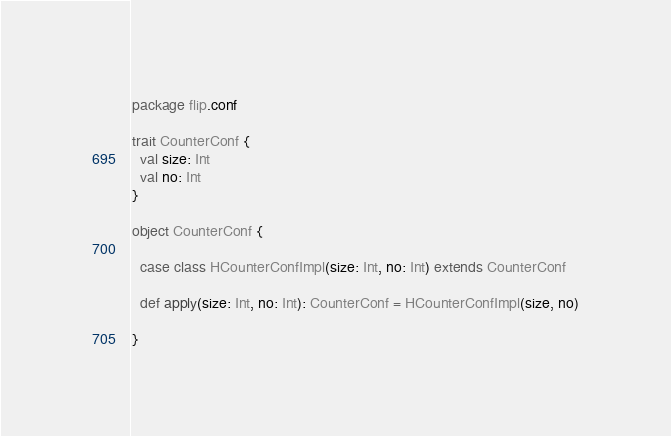Convert code to text. <code><loc_0><loc_0><loc_500><loc_500><_Scala_>package flip.conf

trait CounterConf {
  val size: Int
  val no: Int
}

object CounterConf {

  case class HCounterConfImpl(size: Int, no: Int) extends CounterConf

  def apply(size: Int, no: Int): CounterConf = HCounterConfImpl(size, no)

}
</code> 